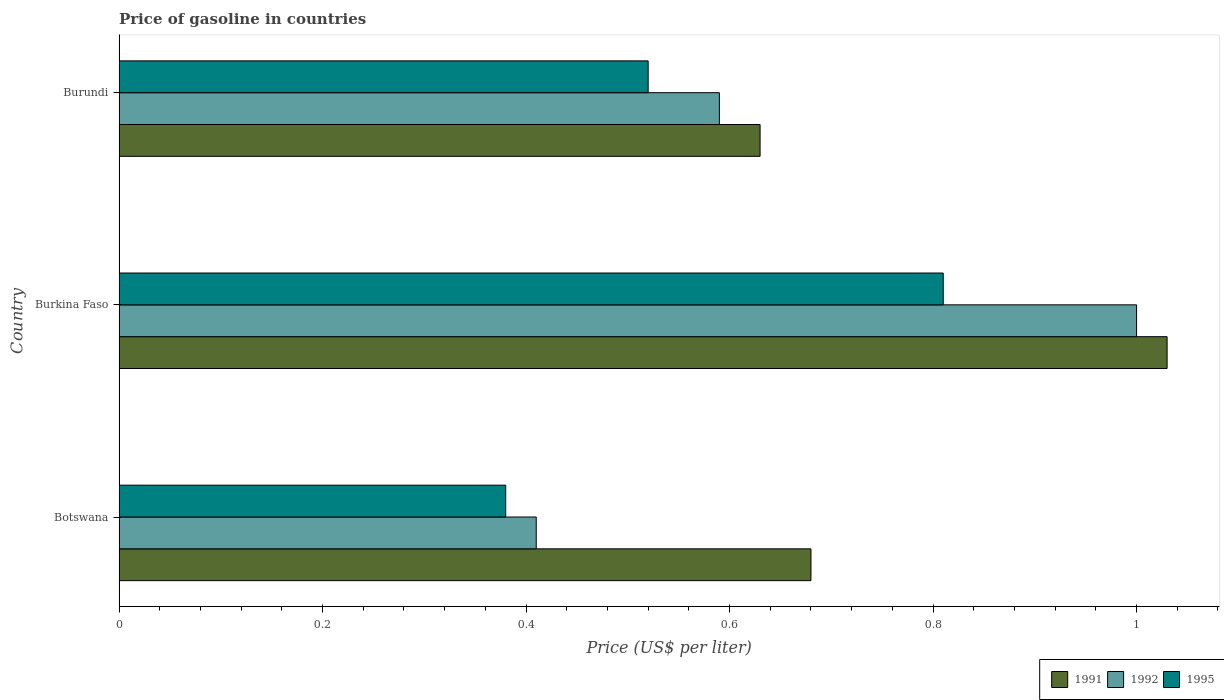How many different coloured bars are there?
Provide a short and direct response. 3. Are the number of bars per tick equal to the number of legend labels?
Ensure brevity in your answer.  Yes. How many bars are there on the 1st tick from the top?
Your response must be concise. 3. What is the label of the 3rd group of bars from the top?
Provide a short and direct response. Botswana. In how many cases, is the number of bars for a given country not equal to the number of legend labels?
Ensure brevity in your answer.  0. What is the price of gasoline in 1992 in Botswana?
Ensure brevity in your answer.  0.41. Across all countries, what is the maximum price of gasoline in 1995?
Your response must be concise. 0.81. Across all countries, what is the minimum price of gasoline in 1991?
Make the answer very short. 0.63. In which country was the price of gasoline in 1992 maximum?
Keep it short and to the point. Burkina Faso. In which country was the price of gasoline in 1991 minimum?
Your answer should be very brief. Burundi. What is the total price of gasoline in 1991 in the graph?
Provide a succinct answer. 2.34. What is the difference between the price of gasoline in 1995 in Botswana and that in Burkina Faso?
Give a very brief answer. -0.43. What is the difference between the price of gasoline in 1992 in Burkina Faso and the price of gasoline in 1991 in Botswana?
Provide a succinct answer. 0.32. What is the average price of gasoline in 1992 per country?
Keep it short and to the point. 0.67. What is the difference between the price of gasoline in 1991 and price of gasoline in 1995 in Botswana?
Your answer should be compact. 0.3. In how many countries, is the price of gasoline in 1995 greater than 0.4 US$?
Provide a succinct answer. 2. What is the ratio of the price of gasoline in 1991 in Burkina Faso to that in Burundi?
Give a very brief answer. 1.63. Is the price of gasoline in 1991 in Botswana less than that in Burundi?
Your answer should be compact. No. Is the difference between the price of gasoline in 1991 in Burkina Faso and Burundi greater than the difference between the price of gasoline in 1995 in Burkina Faso and Burundi?
Offer a very short reply. Yes. What is the difference between the highest and the second highest price of gasoline in 1995?
Your answer should be very brief. 0.29. What is the difference between the highest and the lowest price of gasoline in 1992?
Your answer should be very brief. 0.59. In how many countries, is the price of gasoline in 1992 greater than the average price of gasoline in 1992 taken over all countries?
Provide a succinct answer. 1. Is the sum of the price of gasoline in 1991 in Botswana and Burkina Faso greater than the maximum price of gasoline in 1992 across all countries?
Offer a very short reply. Yes. How many bars are there?
Provide a succinct answer. 9. How many countries are there in the graph?
Offer a very short reply. 3. What is the difference between two consecutive major ticks on the X-axis?
Provide a succinct answer. 0.2. How many legend labels are there?
Make the answer very short. 3. How are the legend labels stacked?
Your answer should be very brief. Horizontal. What is the title of the graph?
Provide a short and direct response. Price of gasoline in countries. What is the label or title of the X-axis?
Your answer should be compact. Price (US$ per liter). What is the label or title of the Y-axis?
Your answer should be very brief. Country. What is the Price (US$ per liter) of 1991 in Botswana?
Make the answer very short. 0.68. What is the Price (US$ per liter) in 1992 in Botswana?
Ensure brevity in your answer.  0.41. What is the Price (US$ per liter) of 1995 in Botswana?
Give a very brief answer. 0.38. What is the Price (US$ per liter) of 1995 in Burkina Faso?
Your response must be concise. 0.81. What is the Price (US$ per liter) of 1991 in Burundi?
Your answer should be compact. 0.63. What is the Price (US$ per liter) in 1992 in Burundi?
Your answer should be very brief. 0.59. What is the Price (US$ per liter) of 1995 in Burundi?
Give a very brief answer. 0.52. Across all countries, what is the maximum Price (US$ per liter) in 1991?
Ensure brevity in your answer.  1.03. Across all countries, what is the maximum Price (US$ per liter) in 1992?
Your response must be concise. 1. Across all countries, what is the maximum Price (US$ per liter) of 1995?
Offer a very short reply. 0.81. Across all countries, what is the minimum Price (US$ per liter) of 1991?
Your response must be concise. 0.63. Across all countries, what is the minimum Price (US$ per liter) of 1992?
Provide a succinct answer. 0.41. Across all countries, what is the minimum Price (US$ per liter) in 1995?
Give a very brief answer. 0.38. What is the total Price (US$ per liter) of 1991 in the graph?
Your answer should be very brief. 2.34. What is the total Price (US$ per liter) of 1992 in the graph?
Provide a succinct answer. 2. What is the total Price (US$ per liter) in 1995 in the graph?
Offer a terse response. 1.71. What is the difference between the Price (US$ per liter) of 1991 in Botswana and that in Burkina Faso?
Provide a short and direct response. -0.35. What is the difference between the Price (US$ per liter) in 1992 in Botswana and that in Burkina Faso?
Your response must be concise. -0.59. What is the difference between the Price (US$ per liter) of 1995 in Botswana and that in Burkina Faso?
Offer a very short reply. -0.43. What is the difference between the Price (US$ per liter) of 1991 in Botswana and that in Burundi?
Keep it short and to the point. 0.05. What is the difference between the Price (US$ per liter) in 1992 in Botswana and that in Burundi?
Provide a succinct answer. -0.18. What is the difference between the Price (US$ per liter) in 1995 in Botswana and that in Burundi?
Provide a succinct answer. -0.14. What is the difference between the Price (US$ per liter) in 1992 in Burkina Faso and that in Burundi?
Keep it short and to the point. 0.41. What is the difference between the Price (US$ per liter) of 1995 in Burkina Faso and that in Burundi?
Ensure brevity in your answer.  0.29. What is the difference between the Price (US$ per liter) of 1991 in Botswana and the Price (US$ per liter) of 1992 in Burkina Faso?
Your answer should be compact. -0.32. What is the difference between the Price (US$ per liter) of 1991 in Botswana and the Price (US$ per liter) of 1995 in Burkina Faso?
Offer a very short reply. -0.13. What is the difference between the Price (US$ per liter) in 1991 in Botswana and the Price (US$ per liter) in 1992 in Burundi?
Your response must be concise. 0.09. What is the difference between the Price (US$ per liter) of 1991 in Botswana and the Price (US$ per liter) of 1995 in Burundi?
Make the answer very short. 0.16. What is the difference between the Price (US$ per liter) in 1992 in Botswana and the Price (US$ per liter) in 1995 in Burundi?
Your answer should be compact. -0.11. What is the difference between the Price (US$ per liter) of 1991 in Burkina Faso and the Price (US$ per liter) of 1992 in Burundi?
Provide a short and direct response. 0.44. What is the difference between the Price (US$ per liter) in 1991 in Burkina Faso and the Price (US$ per liter) in 1995 in Burundi?
Keep it short and to the point. 0.51. What is the difference between the Price (US$ per liter) of 1992 in Burkina Faso and the Price (US$ per liter) of 1995 in Burundi?
Your answer should be compact. 0.48. What is the average Price (US$ per liter) in 1991 per country?
Ensure brevity in your answer.  0.78. What is the average Price (US$ per liter) of 1992 per country?
Provide a short and direct response. 0.67. What is the average Price (US$ per liter) in 1995 per country?
Offer a very short reply. 0.57. What is the difference between the Price (US$ per liter) in 1991 and Price (US$ per liter) in 1992 in Botswana?
Provide a succinct answer. 0.27. What is the difference between the Price (US$ per liter) of 1991 and Price (US$ per liter) of 1995 in Burkina Faso?
Keep it short and to the point. 0.22. What is the difference between the Price (US$ per liter) of 1992 and Price (US$ per liter) of 1995 in Burkina Faso?
Provide a short and direct response. 0.19. What is the difference between the Price (US$ per liter) of 1991 and Price (US$ per liter) of 1992 in Burundi?
Make the answer very short. 0.04. What is the difference between the Price (US$ per liter) in 1991 and Price (US$ per liter) in 1995 in Burundi?
Provide a succinct answer. 0.11. What is the difference between the Price (US$ per liter) in 1992 and Price (US$ per liter) in 1995 in Burundi?
Offer a very short reply. 0.07. What is the ratio of the Price (US$ per liter) in 1991 in Botswana to that in Burkina Faso?
Offer a very short reply. 0.66. What is the ratio of the Price (US$ per liter) of 1992 in Botswana to that in Burkina Faso?
Offer a terse response. 0.41. What is the ratio of the Price (US$ per liter) in 1995 in Botswana to that in Burkina Faso?
Your answer should be very brief. 0.47. What is the ratio of the Price (US$ per liter) in 1991 in Botswana to that in Burundi?
Make the answer very short. 1.08. What is the ratio of the Price (US$ per liter) in 1992 in Botswana to that in Burundi?
Provide a short and direct response. 0.69. What is the ratio of the Price (US$ per liter) of 1995 in Botswana to that in Burundi?
Make the answer very short. 0.73. What is the ratio of the Price (US$ per liter) of 1991 in Burkina Faso to that in Burundi?
Offer a terse response. 1.63. What is the ratio of the Price (US$ per liter) in 1992 in Burkina Faso to that in Burundi?
Your answer should be compact. 1.69. What is the ratio of the Price (US$ per liter) in 1995 in Burkina Faso to that in Burundi?
Make the answer very short. 1.56. What is the difference between the highest and the second highest Price (US$ per liter) in 1991?
Give a very brief answer. 0.35. What is the difference between the highest and the second highest Price (US$ per liter) in 1992?
Keep it short and to the point. 0.41. What is the difference between the highest and the second highest Price (US$ per liter) of 1995?
Provide a short and direct response. 0.29. What is the difference between the highest and the lowest Price (US$ per liter) in 1992?
Give a very brief answer. 0.59. What is the difference between the highest and the lowest Price (US$ per liter) of 1995?
Your response must be concise. 0.43. 